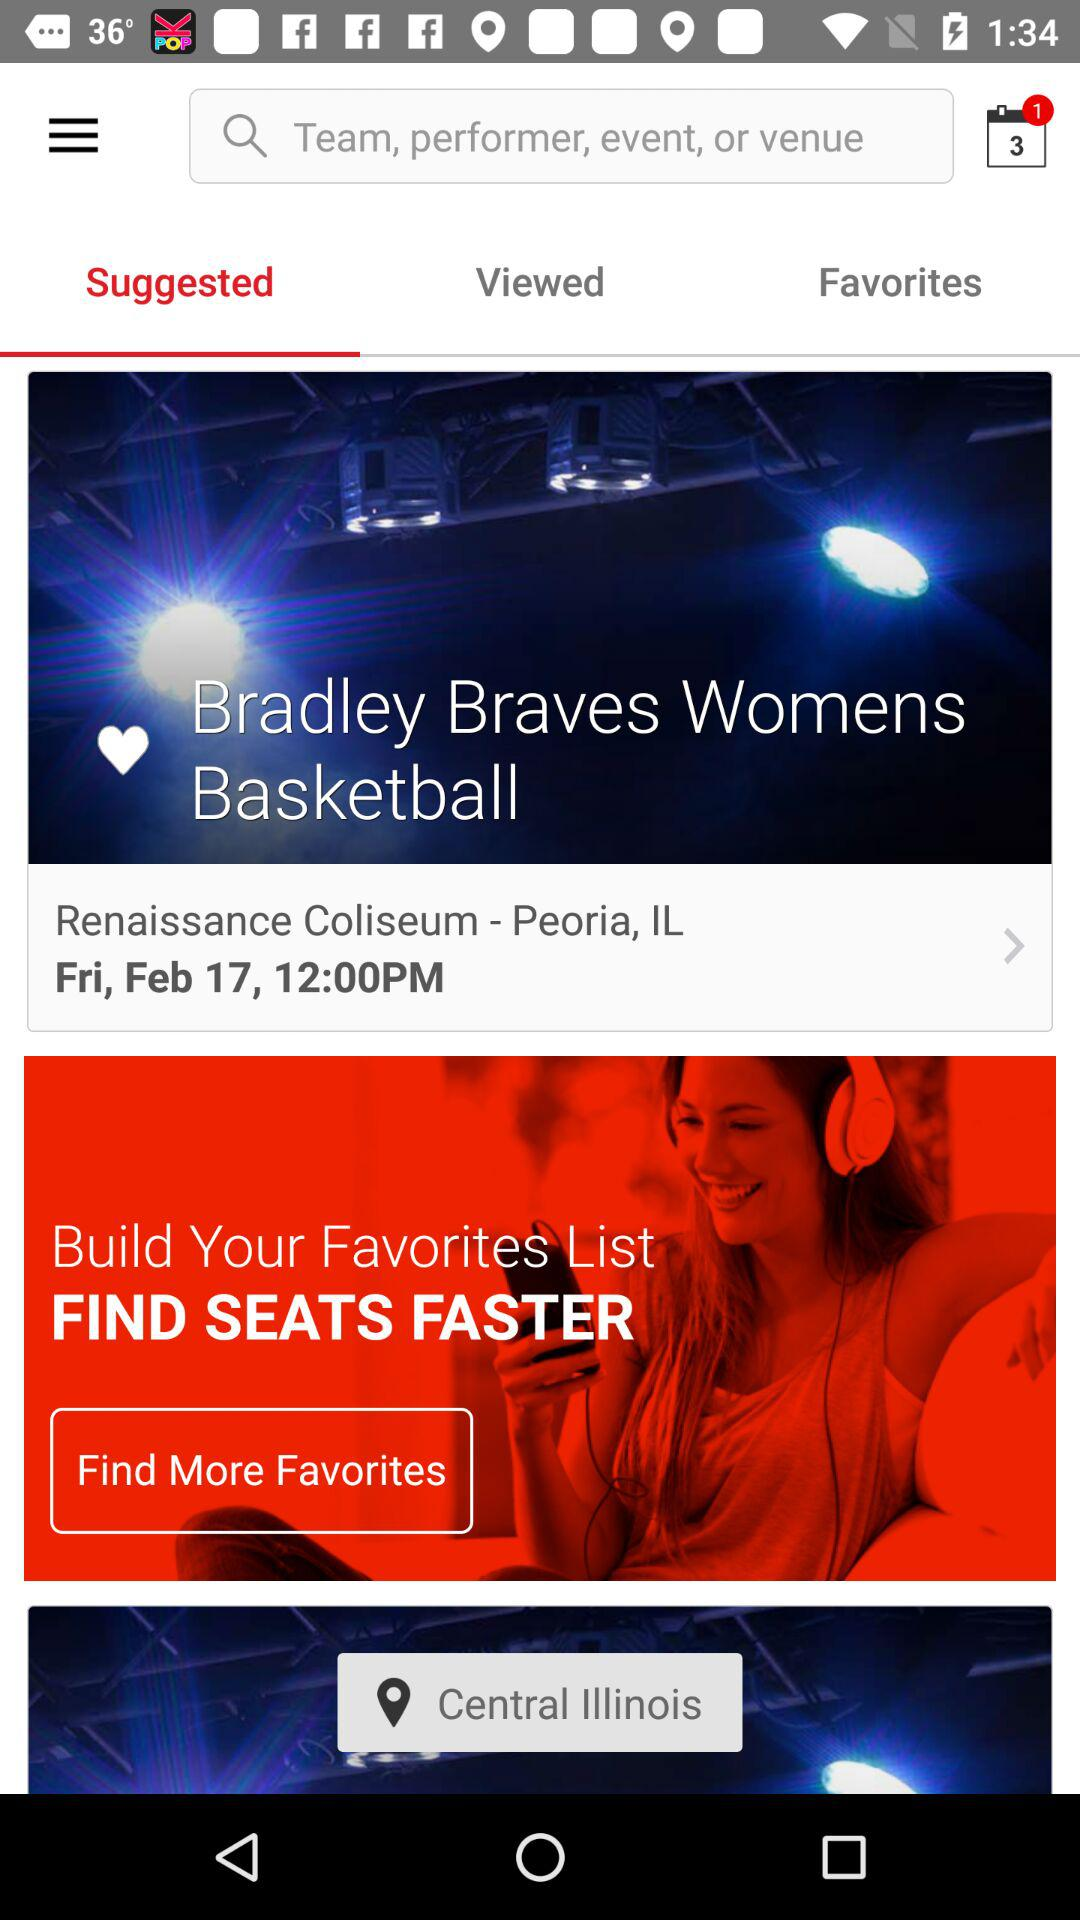What's the venue and location? The venue and location are the Renaissance Coliseum in Chicago and Peoria, IL, respectively. 